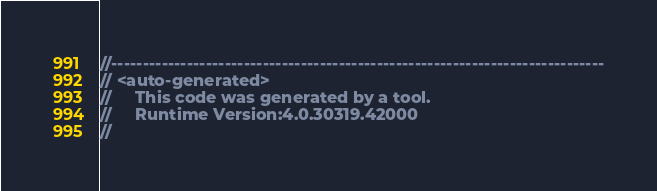<code> <loc_0><loc_0><loc_500><loc_500><_C#_>//------------------------------------------------------------------------------
// <auto-generated>
//     This code was generated by a tool.
//     Runtime Version:4.0.30319.42000
//</code> 